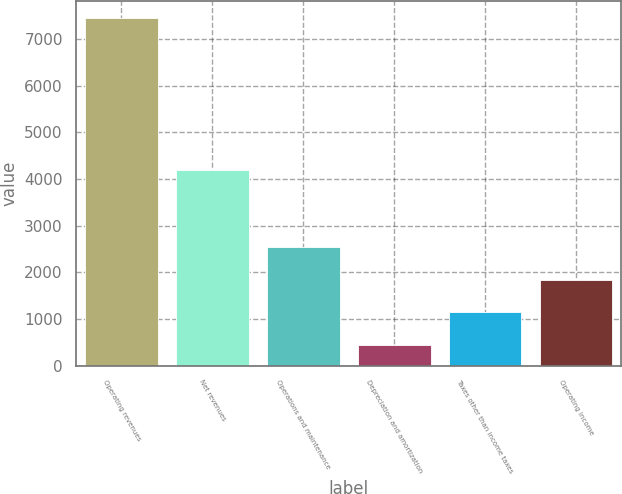Convert chart to OTSL. <chart><loc_0><loc_0><loc_500><loc_500><bar_chart><fcel>Operating revenues<fcel>Net revenues<fcel>Operations and maintenance<fcel>Depreciation and amortization<fcel>Taxes other than income taxes<fcel>Operating income<nl><fcel>7440<fcel>4187<fcel>2545.6<fcel>448<fcel>1147.2<fcel>1846.4<nl></chart> 